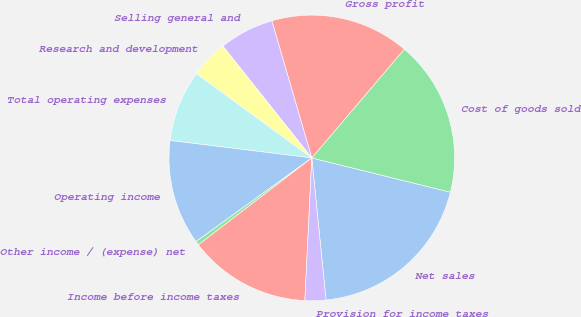Convert chart to OTSL. <chart><loc_0><loc_0><loc_500><loc_500><pie_chart><fcel>Net sales<fcel>Cost of goods sold<fcel>Gross profit<fcel>Selling general and<fcel>Research and development<fcel>Total operating expenses<fcel>Operating income<fcel>Other income / (expense) net<fcel>Income before income taxes<fcel>Provision for income taxes<nl><fcel>19.55%<fcel>17.64%<fcel>15.73%<fcel>6.18%<fcel>4.27%<fcel>8.09%<fcel>11.91%<fcel>0.45%<fcel>13.82%<fcel>2.36%<nl></chart> 